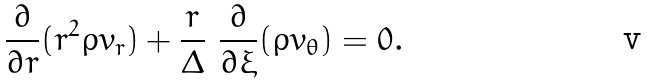Convert formula to latex. <formula><loc_0><loc_0><loc_500><loc_500>\frac { \partial } { \partial r } ( r ^ { 2 } \rho v _ { r } ) + \frac { r } { \Delta } \ \frac { \partial } { \partial \xi } ( \rho v _ { \theta } ) = 0 .</formula> 